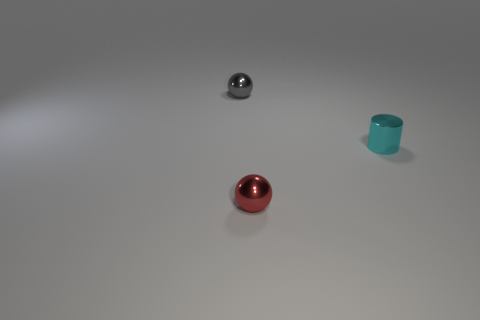Add 1 big cyan metal things. How many objects exist? 4 Subtract all cylinders. How many objects are left? 2 Subtract 0 brown cylinders. How many objects are left? 3 Subtract all tiny gray metallic objects. Subtract all gray metallic objects. How many objects are left? 1 Add 2 tiny gray balls. How many tiny gray balls are left? 3 Add 1 small red spheres. How many small red spheres exist? 2 